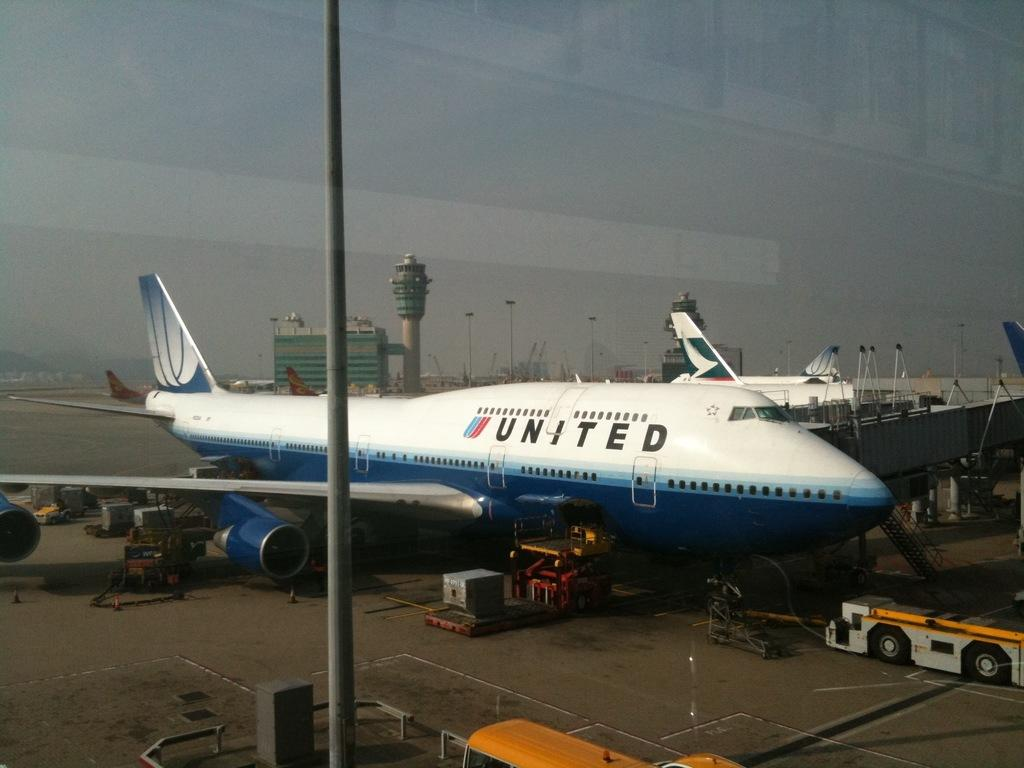Provide a one-sentence caption for the provided image. A United aeroplane waiting on tarmac on a sunny day. 